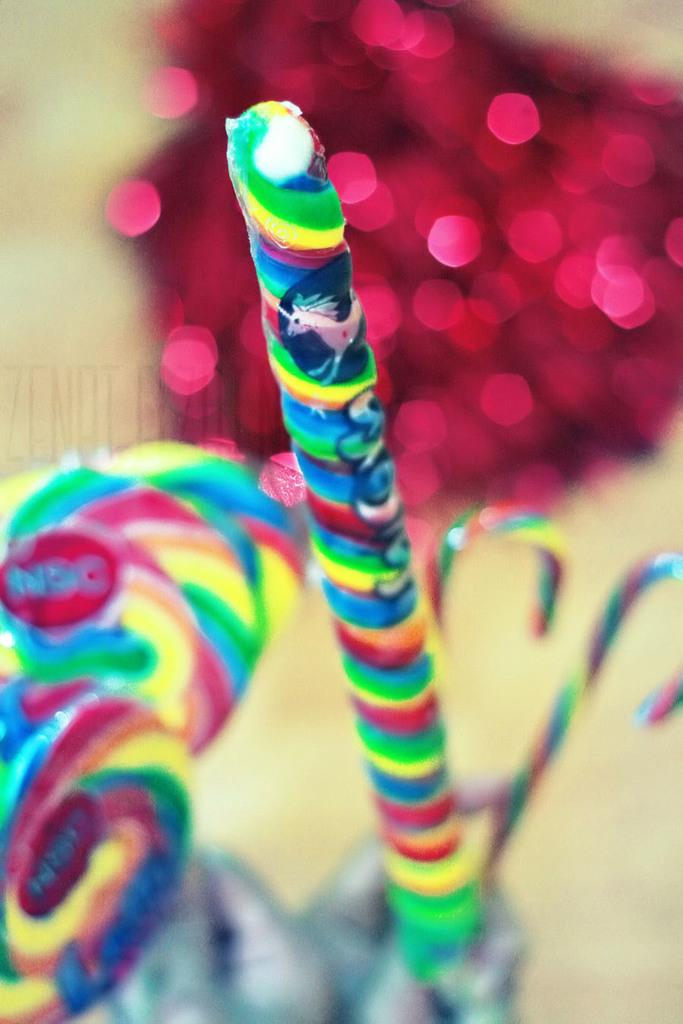What type of food can be seen in the image? There are candies in the image. Can you describe the background of the image? The background of the image is blurry. What type of plastic can be seen floating in the ocean in the image? There is no ocean or plastic present in the image; it only features candies and a blurry background. 